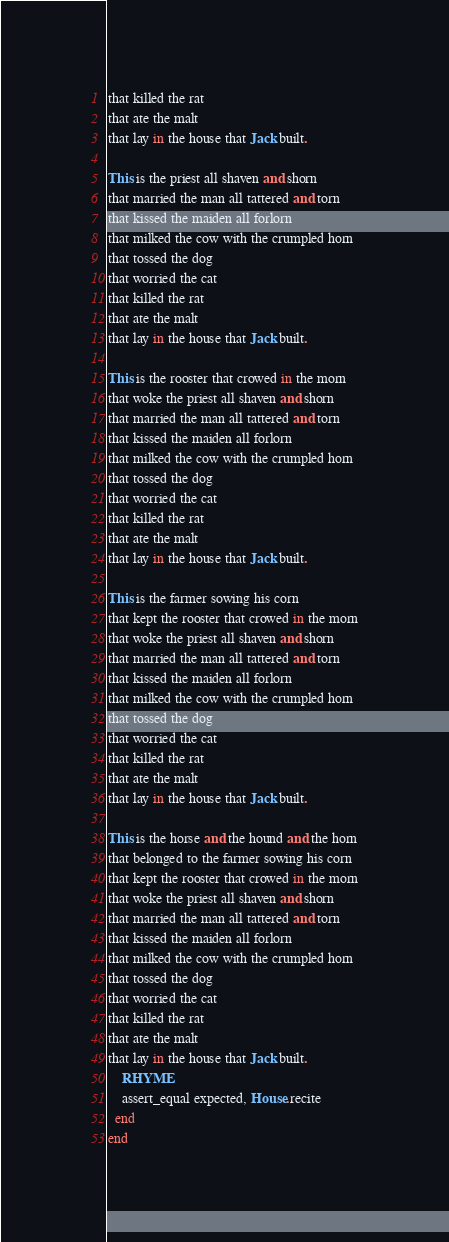Convert code to text. <code><loc_0><loc_0><loc_500><loc_500><_Ruby_>that killed the rat
that ate the malt
that lay in the house that Jack built.

This is the priest all shaven and shorn
that married the man all tattered and torn
that kissed the maiden all forlorn
that milked the cow with the crumpled horn
that tossed the dog
that worried the cat
that killed the rat
that ate the malt
that lay in the house that Jack built.

This is the rooster that crowed in the morn
that woke the priest all shaven and shorn
that married the man all tattered and torn
that kissed the maiden all forlorn
that milked the cow with the crumpled horn
that tossed the dog
that worried the cat
that killed the rat
that ate the malt
that lay in the house that Jack built.

This is the farmer sowing his corn
that kept the rooster that crowed in the morn
that woke the priest all shaven and shorn
that married the man all tattered and torn
that kissed the maiden all forlorn
that milked the cow with the crumpled horn
that tossed the dog
that worried the cat
that killed the rat
that ate the malt
that lay in the house that Jack built.

This is the horse and the hound and the horn
that belonged to the farmer sowing his corn
that kept the rooster that crowed in the morn
that woke the priest all shaven and shorn
that married the man all tattered and torn
that kissed the maiden all forlorn
that milked the cow with the crumpled horn
that tossed the dog
that worried the cat
that killed the rat
that ate the malt
that lay in the house that Jack built.
    RHYME
    assert_equal expected, House.recite
  end
end
</code> 